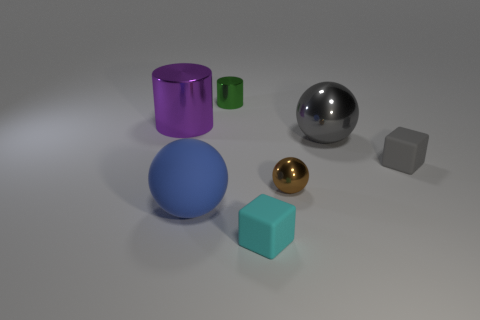Is there any other thing that is the same material as the brown ball?
Make the answer very short. Yes. There is a rubber ball; is its size the same as the object that is left of the blue sphere?
Your response must be concise. Yes. What number of other objects are the same color as the large shiny sphere?
Offer a terse response. 1. There is a big blue thing; are there any big blue matte things left of it?
Keep it short and to the point. No. How many objects are large blue rubber objects or blocks that are left of the small gray object?
Your response must be concise. 2. There is a tiny metal thing behind the large purple metal cylinder; is there a purple cylinder right of it?
Give a very brief answer. No. What is the shape of the small metal thing that is in front of the large ball that is on the right side of the rubber cube in front of the small brown metal thing?
Offer a terse response. Sphere. There is a sphere that is in front of the gray rubber cube and on the right side of the cyan rubber cube; what color is it?
Your response must be concise. Brown. The large matte thing that is in front of the green metal cylinder has what shape?
Offer a terse response. Sphere. What is the shape of the big thing that is made of the same material as the gray cube?
Offer a very short reply. Sphere. 